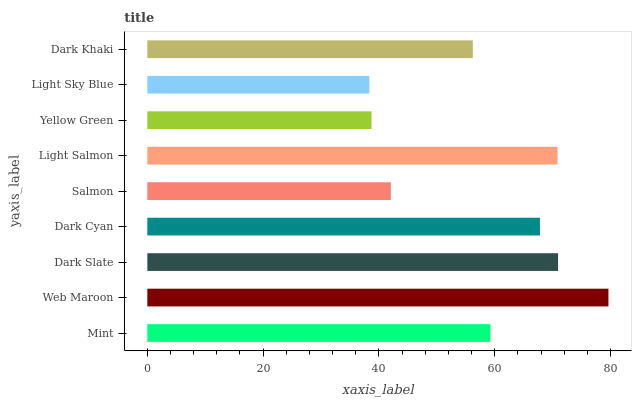Is Light Sky Blue the minimum?
Answer yes or no. Yes. Is Web Maroon the maximum?
Answer yes or no. Yes. Is Dark Slate the minimum?
Answer yes or no. No. Is Dark Slate the maximum?
Answer yes or no. No. Is Web Maroon greater than Dark Slate?
Answer yes or no. Yes. Is Dark Slate less than Web Maroon?
Answer yes or no. Yes. Is Dark Slate greater than Web Maroon?
Answer yes or no. No. Is Web Maroon less than Dark Slate?
Answer yes or no. No. Is Mint the high median?
Answer yes or no. Yes. Is Mint the low median?
Answer yes or no. Yes. Is Web Maroon the high median?
Answer yes or no. No. Is Light Salmon the low median?
Answer yes or no. No. 